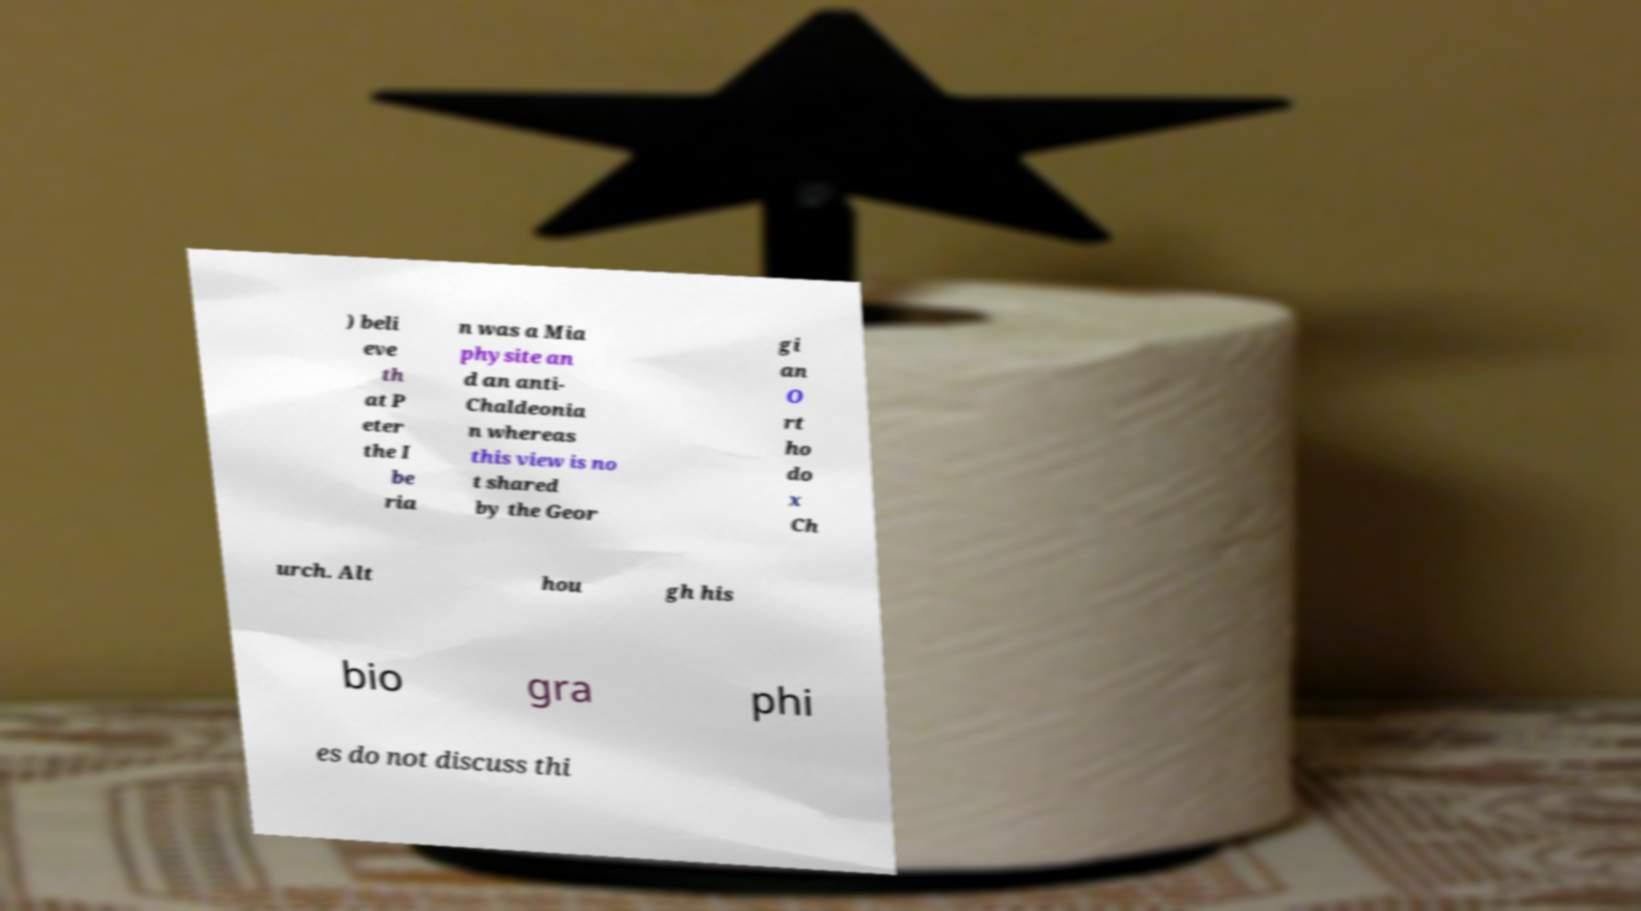What messages or text are displayed in this image? I need them in a readable, typed format. ) beli eve th at P eter the I be ria n was a Mia physite an d an anti- Chaldeonia n whereas this view is no t shared by the Geor gi an O rt ho do x Ch urch. Alt hou gh his bio gra phi es do not discuss thi 